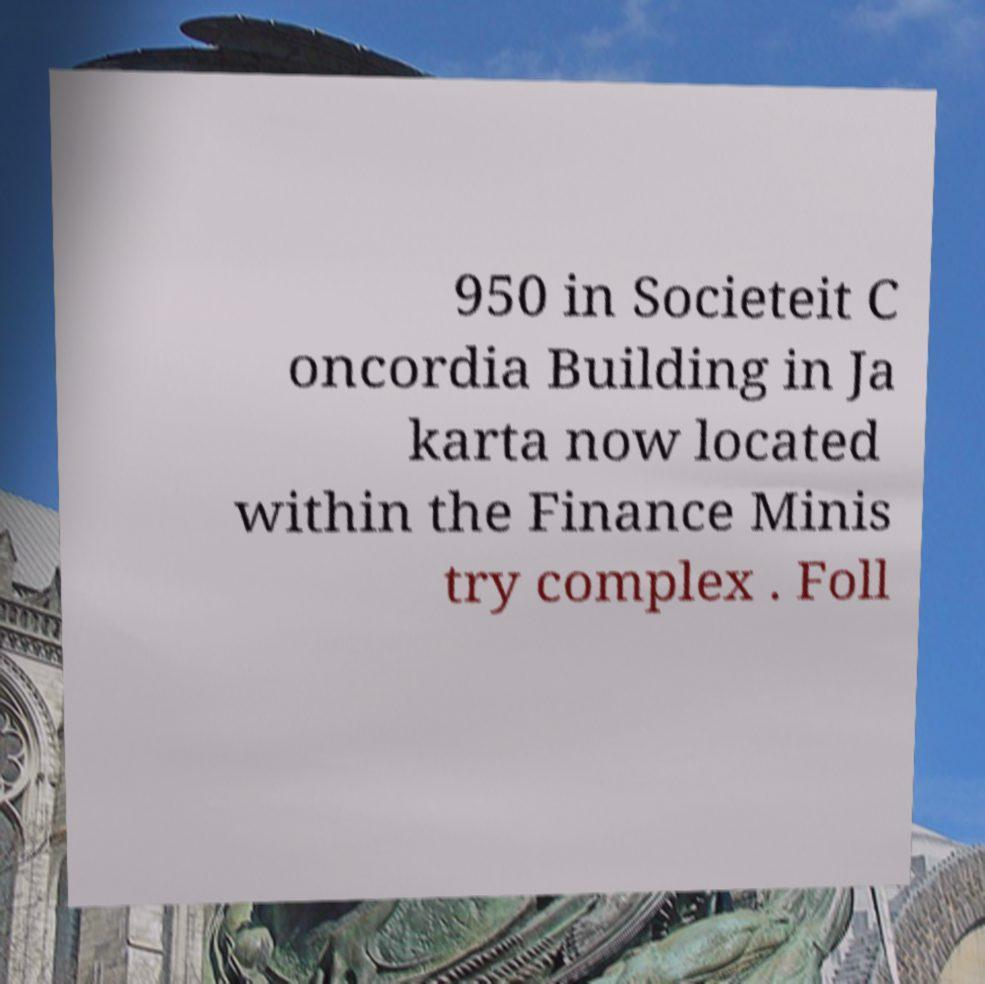There's text embedded in this image that I need extracted. Can you transcribe it verbatim? 950 in Societeit C oncordia Building in Ja karta now located within the Finance Minis try complex . Foll 